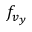<formula> <loc_0><loc_0><loc_500><loc_500>f _ { v _ { y } }</formula> 